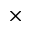Convert formula to latex. <formula><loc_0><loc_0><loc_500><loc_500>\times</formula> 